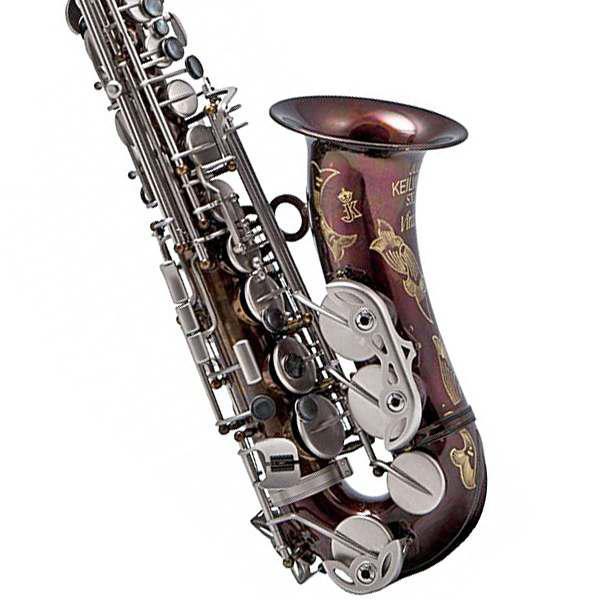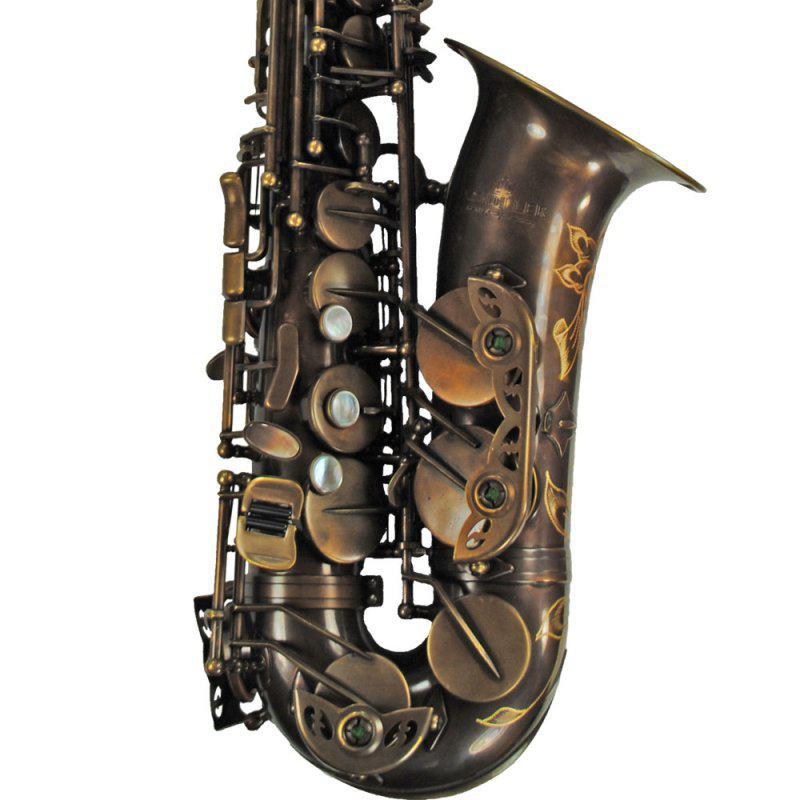The first image is the image on the left, the second image is the image on the right. Examine the images to the left and right. Is the description "The saxophones are all sitting upright and facing to the right." accurate? Answer yes or no. Yes. The first image is the image on the left, the second image is the image on the right. Given the left and right images, does the statement "There is a vintage saxophone in the center of both images." hold true? Answer yes or no. Yes. 